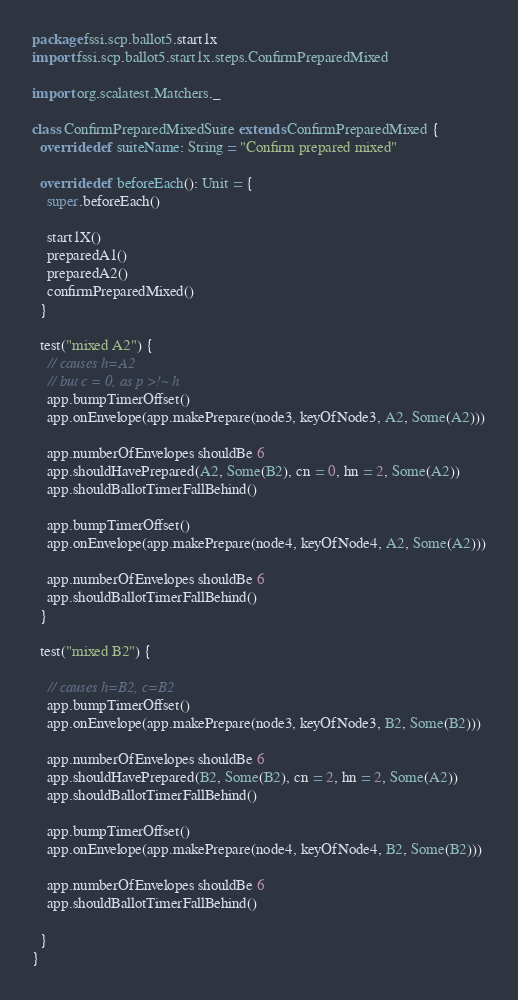<code> <loc_0><loc_0><loc_500><loc_500><_Scala_>package fssi.scp.ballot5.start1x
import fssi.scp.ballot5.start1x.steps.ConfirmPreparedMixed

import org.scalatest.Matchers._

class ConfirmPreparedMixedSuite extends ConfirmPreparedMixed {
  override def suiteName: String = "Confirm prepared mixed"

  override def beforeEach(): Unit = {
    super.beforeEach()

    start1X()
    preparedA1()
    preparedA2()
    confirmPreparedMixed()
  }

  test("mixed A2") {
    // causes h=A2
    // but c = 0, as p >!~ h
    app.bumpTimerOffset()
    app.onEnvelope(app.makePrepare(node3, keyOfNode3, A2, Some(A2)))

    app.numberOfEnvelopes shouldBe 6
    app.shouldHavePrepared(A2, Some(B2), cn = 0, hn = 2, Some(A2))
    app.shouldBallotTimerFallBehind()

    app.bumpTimerOffset()
    app.onEnvelope(app.makePrepare(node4, keyOfNode4, A2, Some(A2)))

    app.numberOfEnvelopes shouldBe 6
    app.shouldBallotTimerFallBehind()
  }

  test("mixed B2") {

    // causes h=B2, c=B2
    app.bumpTimerOffset()
    app.onEnvelope(app.makePrepare(node3, keyOfNode3, B2, Some(B2)))

    app.numberOfEnvelopes shouldBe 6
    app.shouldHavePrepared(B2, Some(B2), cn = 2, hn = 2, Some(A2))
    app.shouldBallotTimerFallBehind()

    app.bumpTimerOffset()
    app.onEnvelope(app.makePrepare(node4, keyOfNode4, B2, Some(B2)))

    app.numberOfEnvelopes shouldBe 6
    app.shouldBallotTimerFallBehind()

  }
}
</code> 